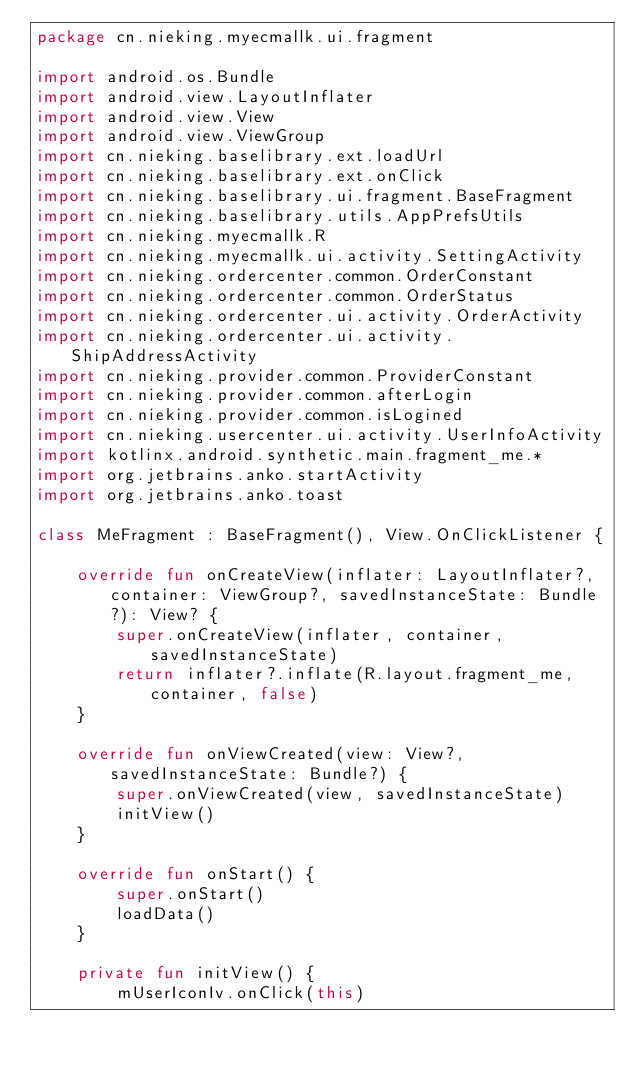Convert code to text. <code><loc_0><loc_0><loc_500><loc_500><_Kotlin_>package cn.nieking.myecmallk.ui.fragment

import android.os.Bundle
import android.view.LayoutInflater
import android.view.View
import android.view.ViewGroup
import cn.nieking.baselibrary.ext.loadUrl
import cn.nieking.baselibrary.ext.onClick
import cn.nieking.baselibrary.ui.fragment.BaseFragment
import cn.nieking.baselibrary.utils.AppPrefsUtils
import cn.nieking.myecmallk.R
import cn.nieking.myecmallk.ui.activity.SettingActivity
import cn.nieking.ordercenter.common.OrderConstant
import cn.nieking.ordercenter.common.OrderStatus
import cn.nieking.ordercenter.ui.activity.OrderActivity
import cn.nieking.ordercenter.ui.activity.ShipAddressActivity
import cn.nieking.provider.common.ProviderConstant
import cn.nieking.provider.common.afterLogin
import cn.nieking.provider.common.isLogined
import cn.nieking.usercenter.ui.activity.UserInfoActivity
import kotlinx.android.synthetic.main.fragment_me.*
import org.jetbrains.anko.startActivity
import org.jetbrains.anko.toast

class MeFragment : BaseFragment(), View.OnClickListener {

    override fun onCreateView(inflater: LayoutInflater?, container: ViewGroup?, savedInstanceState: Bundle?): View? {
        super.onCreateView(inflater, container, savedInstanceState)
        return inflater?.inflate(R.layout.fragment_me, container, false)
    }

    override fun onViewCreated(view: View?, savedInstanceState: Bundle?) {
        super.onViewCreated(view, savedInstanceState)
        initView()
    }

    override fun onStart() {
        super.onStart()
        loadData()
    }

    private fun initView() {
        mUserIconIv.onClick(this)</code> 